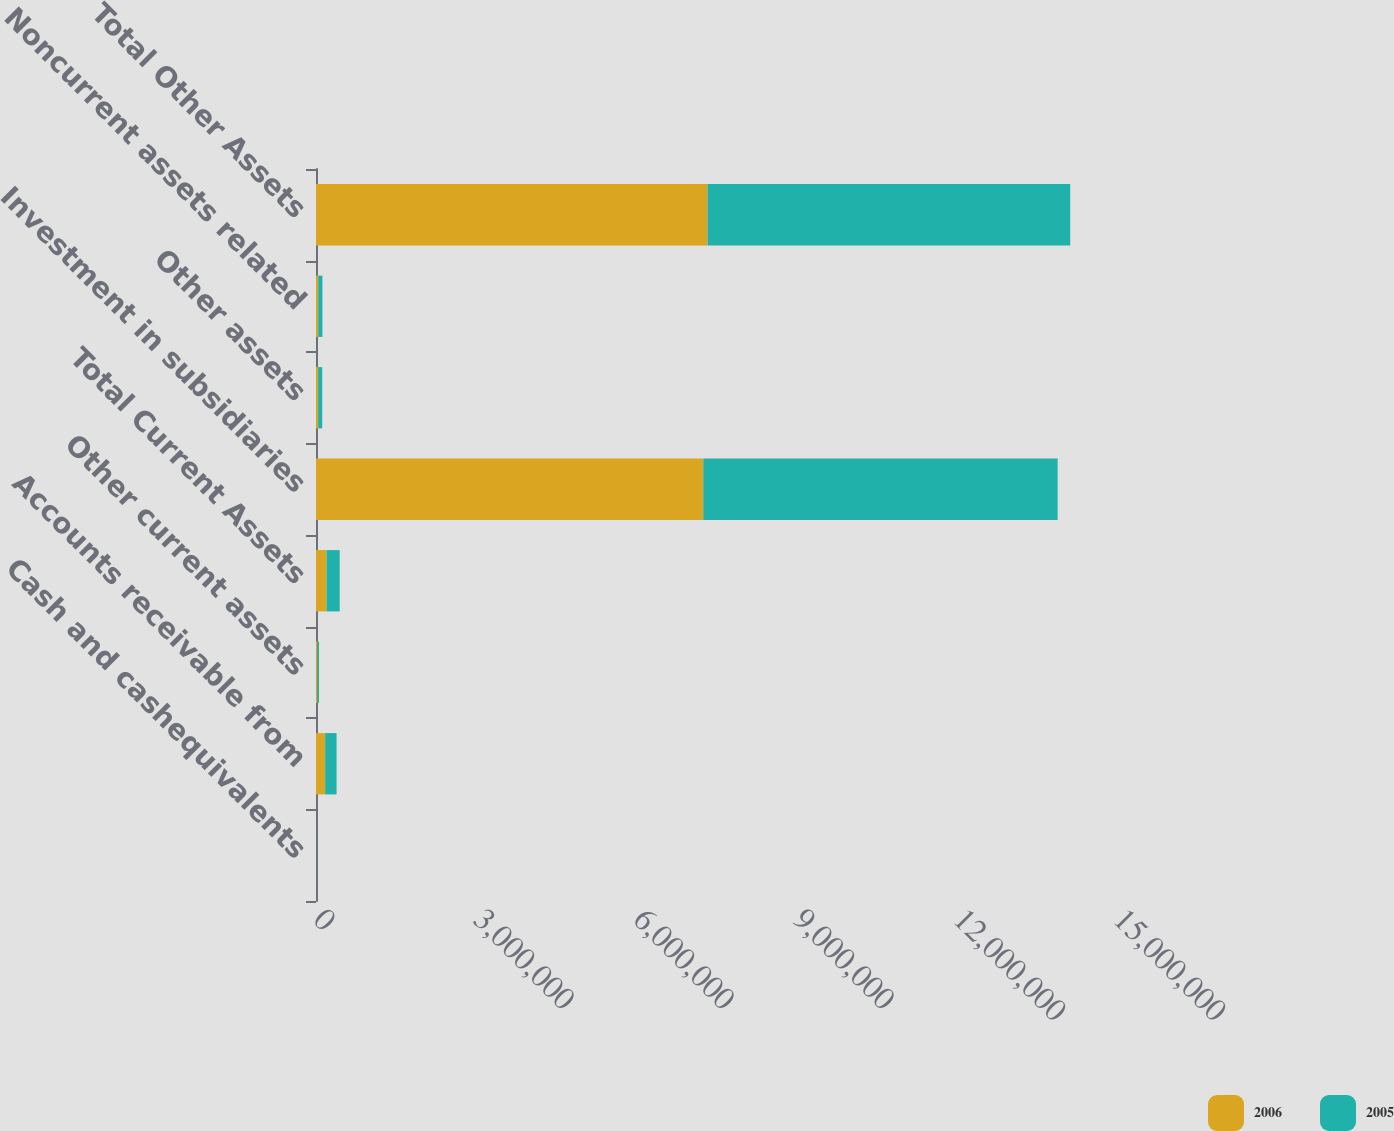Convert chart to OTSL. <chart><loc_0><loc_0><loc_500><loc_500><stacked_bar_chart><ecel><fcel>Cash and cashequivalents<fcel>Accounts receivable from<fcel>Other current assets<fcel>Total Current Assets<fcel>Investment in subsidiaries<fcel>Other assets<fcel>Noncurrent assets related<fcel>Total Other Assets<nl><fcel>2006<fcel>523<fcel>171434<fcel>26443<fcel>198400<fcel>7.26152e+06<fcel>39998<fcel>40152<fcel>7.34166e+06<nl><fcel>2005<fcel>1167<fcel>214271<fcel>30542<fcel>245980<fcel>6.64411e+06<fcel>76067<fcel>80101<fcel>6.80028e+06<nl></chart> 